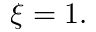Convert formula to latex. <formula><loc_0><loc_0><loc_500><loc_500>\xi = 1 .</formula> 